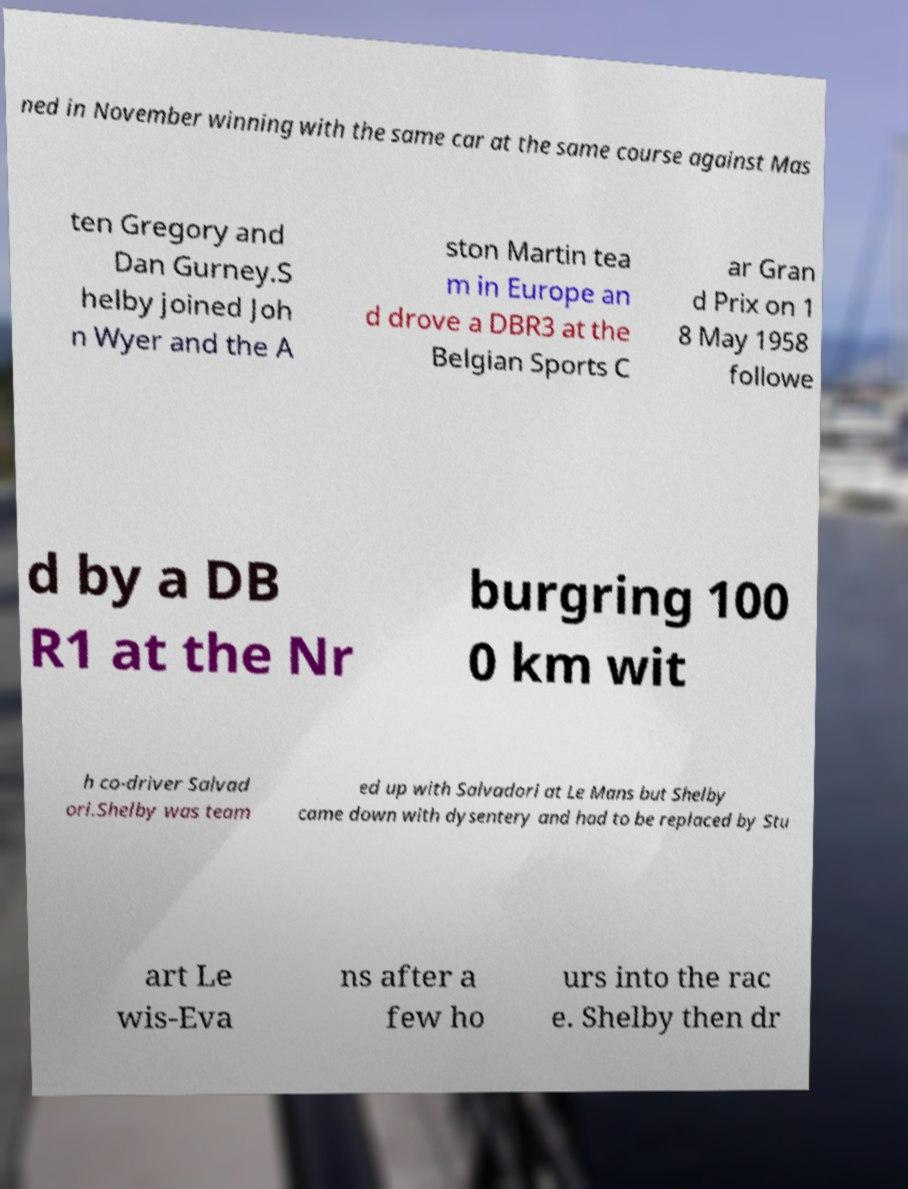There's text embedded in this image that I need extracted. Can you transcribe it verbatim? ned in November winning with the same car at the same course against Mas ten Gregory and Dan Gurney.S helby joined Joh n Wyer and the A ston Martin tea m in Europe an d drove a DBR3 at the Belgian Sports C ar Gran d Prix on 1 8 May 1958 followe d by a DB R1 at the Nr burgring 100 0 km wit h co-driver Salvad ori.Shelby was team ed up with Salvadori at Le Mans but Shelby came down with dysentery and had to be replaced by Stu art Le wis-Eva ns after a few ho urs into the rac e. Shelby then dr 